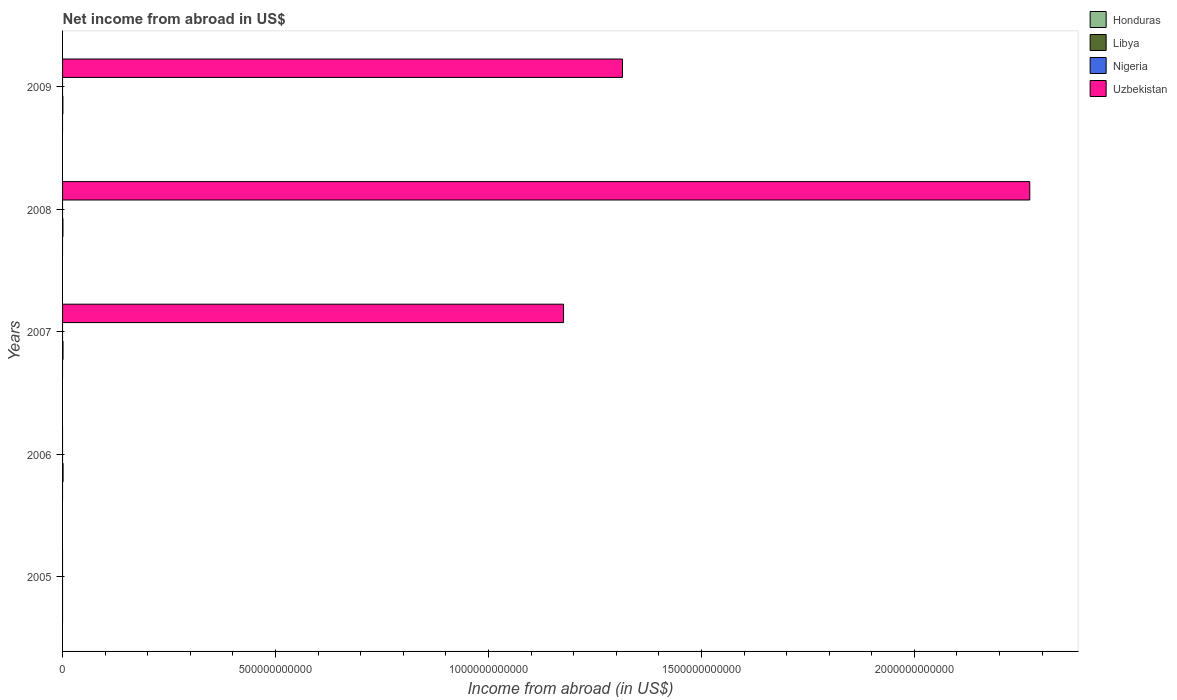How many different coloured bars are there?
Ensure brevity in your answer.  2. Are the number of bars on each tick of the Y-axis equal?
Make the answer very short. No. What is the label of the 3rd group of bars from the top?
Provide a short and direct response. 2007. In how many cases, is the number of bars for a given year not equal to the number of legend labels?
Make the answer very short. 5. What is the net income from abroad in Nigeria in 2006?
Offer a very short reply. 0. Across all years, what is the maximum net income from abroad in Uzbekistan?
Make the answer very short. 2.27e+12. What is the total net income from abroad in Uzbekistan in the graph?
Give a very brief answer. 4.76e+12. What is the difference between the net income from abroad in Libya in 2008 and that in 2009?
Offer a terse response. 1.42e+08. What is the difference between the net income from abroad in Libya in 2006 and the net income from abroad in Nigeria in 2009?
Offer a very short reply. 1.20e+09. What is the average net income from abroad in Nigeria per year?
Provide a short and direct response. 0. In how many years, is the net income from abroad in Libya greater than 1400000000000 US$?
Provide a short and direct response. 0. What is the ratio of the net income from abroad in Libya in 2008 to that in 2009?
Offer a very short reply. 1.2. Is the net income from abroad in Libya in 2007 less than that in 2009?
Keep it short and to the point. No. What is the difference between the highest and the second highest net income from abroad in Libya?
Your answer should be very brief. 1.52e+08. What is the difference between the highest and the lowest net income from abroad in Uzbekistan?
Provide a short and direct response. 2.27e+12. In how many years, is the net income from abroad in Nigeria greater than the average net income from abroad in Nigeria taken over all years?
Ensure brevity in your answer.  0. Is it the case that in every year, the sum of the net income from abroad in Libya and net income from abroad in Uzbekistan is greater than the sum of net income from abroad in Nigeria and net income from abroad in Honduras?
Provide a succinct answer. No. How many bars are there?
Provide a succinct answer. 7. How many years are there in the graph?
Provide a short and direct response. 5. What is the difference between two consecutive major ticks on the X-axis?
Provide a succinct answer. 5.00e+11. Are the values on the major ticks of X-axis written in scientific E-notation?
Your response must be concise. No. Does the graph contain grids?
Your response must be concise. No. How are the legend labels stacked?
Your response must be concise. Vertical. What is the title of the graph?
Ensure brevity in your answer.  Net income from abroad in US$. What is the label or title of the X-axis?
Your answer should be compact. Income from abroad (in US$). What is the Income from abroad (in US$) of Libya in 2005?
Your response must be concise. 0. What is the Income from abroad (in US$) of Libya in 2006?
Your response must be concise. 1.20e+09. What is the Income from abroad (in US$) in Nigeria in 2006?
Ensure brevity in your answer.  0. What is the Income from abroad (in US$) in Honduras in 2007?
Ensure brevity in your answer.  0. What is the Income from abroad (in US$) of Libya in 2007?
Your answer should be compact. 1.05e+09. What is the Income from abroad (in US$) in Nigeria in 2007?
Your answer should be compact. 0. What is the Income from abroad (in US$) in Uzbekistan in 2007?
Offer a very short reply. 1.18e+12. What is the Income from abroad (in US$) in Libya in 2008?
Your answer should be compact. 8.63e+08. What is the Income from abroad (in US$) in Nigeria in 2008?
Offer a very short reply. 0. What is the Income from abroad (in US$) in Uzbekistan in 2008?
Provide a short and direct response. 2.27e+12. What is the Income from abroad (in US$) in Honduras in 2009?
Your answer should be very brief. 0. What is the Income from abroad (in US$) in Libya in 2009?
Offer a very short reply. 7.21e+08. What is the Income from abroad (in US$) in Nigeria in 2009?
Provide a succinct answer. 0. What is the Income from abroad (in US$) in Uzbekistan in 2009?
Your answer should be compact. 1.31e+12. Across all years, what is the maximum Income from abroad (in US$) in Libya?
Give a very brief answer. 1.20e+09. Across all years, what is the maximum Income from abroad (in US$) of Uzbekistan?
Keep it short and to the point. 2.27e+12. Across all years, what is the minimum Income from abroad (in US$) in Libya?
Your answer should be very brief. 0. Across all years, what is the minimum Income from abroad (in US$) of Uzbekistan?
Your response must be concise. 0. What is the total Income from abroad (in US$) in Honduras in the graph?
Your response must be concise. 0. What is the total Income from abroad (in US$) in Libya in the graph?
Your answer should be very brief. 3.84e+09. What is the total Income from abroad (in US$) in Uzbekistan in the graph?
Offer a terse response. 4.76e+12. What is the difference between the Income from abroad (in US$) in Libya in 2006 and that in 2007?
Ensure brevity in your answer.  1.52e+08. What is the difference between the Income from abroad (in US$) of Libya in 2006 and that in 2008?
Ensure brevity in your answer.  3.40e+08. What is the difference between the Income from abroad (in US$) in Libya in 2006 and that in 2009?
Your response must be concise. 4.82e+08. What is the difference between the Income from abroad (in US$) of Libya in 2007 and that in 2008?
Make the answer very short. 1.88e+08. What is the difference between the Income from abroad (in US$) in Uzbekistan in 2007 and that in 2008?
Give a very brief answer. -1.09e+12. What is the difference between the Income from abroad (in US$) of Libya in 2007 and that in 2009?
Make the answer very short. 3.30e+08. What is the difference between the Income from abroad (in US$) of Uzbekistan in 2007 and that in 2009?
Keep it short and to the point. -1.38e+11. What is the difference between the Income from abroad (in US$) of Libya in 2008 and that in 2009?
Make the answer very short. 1.42e+08. What is the difference between the Income from abroad (in US$) in Uzbekistan in 2008 and that in 2009?
Ensure brevity in your answer.  9.56e+11. What is the difference between the Income from abroad (in US$) in Libya in 2006 and the Income from abroad (in US$) in Uzbekistan in 2007?
Your answer should be compact. -1.18e+12. What is the difference between the Income from abroad (in US$) in Libya in 2006 and the Income from abroad (in US$) in Uzbekistan in 2008?
Your answer should be compact. -2.27e+12. What is the difference between the Income from abroad (in US$) in Libya in 2006 and the Income from abroad (in US$) in Uzbekistan in 2009?
Offer a very short reply. -1.31e+12. What is the difference between the Income from abroad (in US$) in Libya in 2007 and the Income from abroad (in US$) in Uzbekistan in 2008?
Your answer should be compact. -2.27e+12. What is the difference between the Income from abroad (in US$) of Libya in 2007 and the Income from abroad (in US$) of Uzbekistan in 2009?
Offer a very short reply. -1.31e+12. What is the difference between the Income from abroad (in US$) in Libya in 2008 and the Income from abroad (in US$) in Uzbekistan in 2009?
Offer a terse response. -1.31e+12. What is the average Income from abroad (in US$) in Honduras per year?
Make the answer very short. 0. What is the average Income from abroad (in US$) in Libya per year?
Provide a succinct answer. 7.68e+08. What is the average Income from abroad (in US$) in Nigeria per year?
Your response must be concise. 0. What is the average Income from abroad (in US$) of Uzbekistan per year?
Make the answer very short. 9.52e+11. In the year 2007, what is the difference between the Income from abroad (in US$) of Libya and Income from abroad (in US$) of Uzbekistan?
Provide a short and direct response. -1.18e+12. In the year 2008, what is the difference between the Income from abroad (in US$) of Libya and Income from abroad (in US$) of Uzbekistan?
Make the answer very short. -2.27e+12. In the year 2009, what is the difference between the Income from abroad (in US$) of Libya and Income from abroad (in US$) of Uzbekistan?
Your response must be concise. -1.31e+12. What is the ratio of the Income from abroad (in US$) in Libya in 2006 to that in 2007?
Offer a very short reply. 1.14. What is the ratio of the Income from abroad (in US$) in Libya in 2006 to that in 2008?
Your answer should be very brief. 1.39. What is the ratio of the Income from abroad (in US$) of Libya in 2006 to that in 2009?
Give a very brief answer. 1.67. What is the ratio of the Income from abroad (in US$) of Libya in 2007 to that in 2008?
Your answer should be very brief. 1.22. What is the ratio of the Income from abroad (in US$) in Uzbekistan in 2007 to that in 2008?
Offer a terse response. 0.52. What is the ratio of the Income from abroad (in US$) in Libya in 2007 to that in 2009?
Your response must be concise. 1.46. What is the ratio of the Income from abroad (in US$) of Uzbekistan in 2007 to that in 2009?
Give a very brief answer. 0.89. What is the ratio of the Income from abroad (in US$) of Libya in 2008 to that in 2009?
Your answer should be compact. 1.2. What is the ratio of the Income from abroad (in US$) in Uzbekistan in 2008 to that in 2009?
Your response must be concise. 1.73. What is the difference between the highest and the second highest Income from abroad (in US$) in Libya?
Offer a terse response. 1.52e+08. What is the difference between the highest and the second highest Income from abroad (in US$) in Uzbekistan?
Provide a succinct answer. 9.56e+11. What is the difference between the highest and the lowest Income from abroad (in US$) of Libya?
Provide a short and direct response. 1.20e+09. What is the difference between the highest and the lowest Income from abroad (in US$) in Uzbekistan?
Your response must be concise. 2.27e+12. 